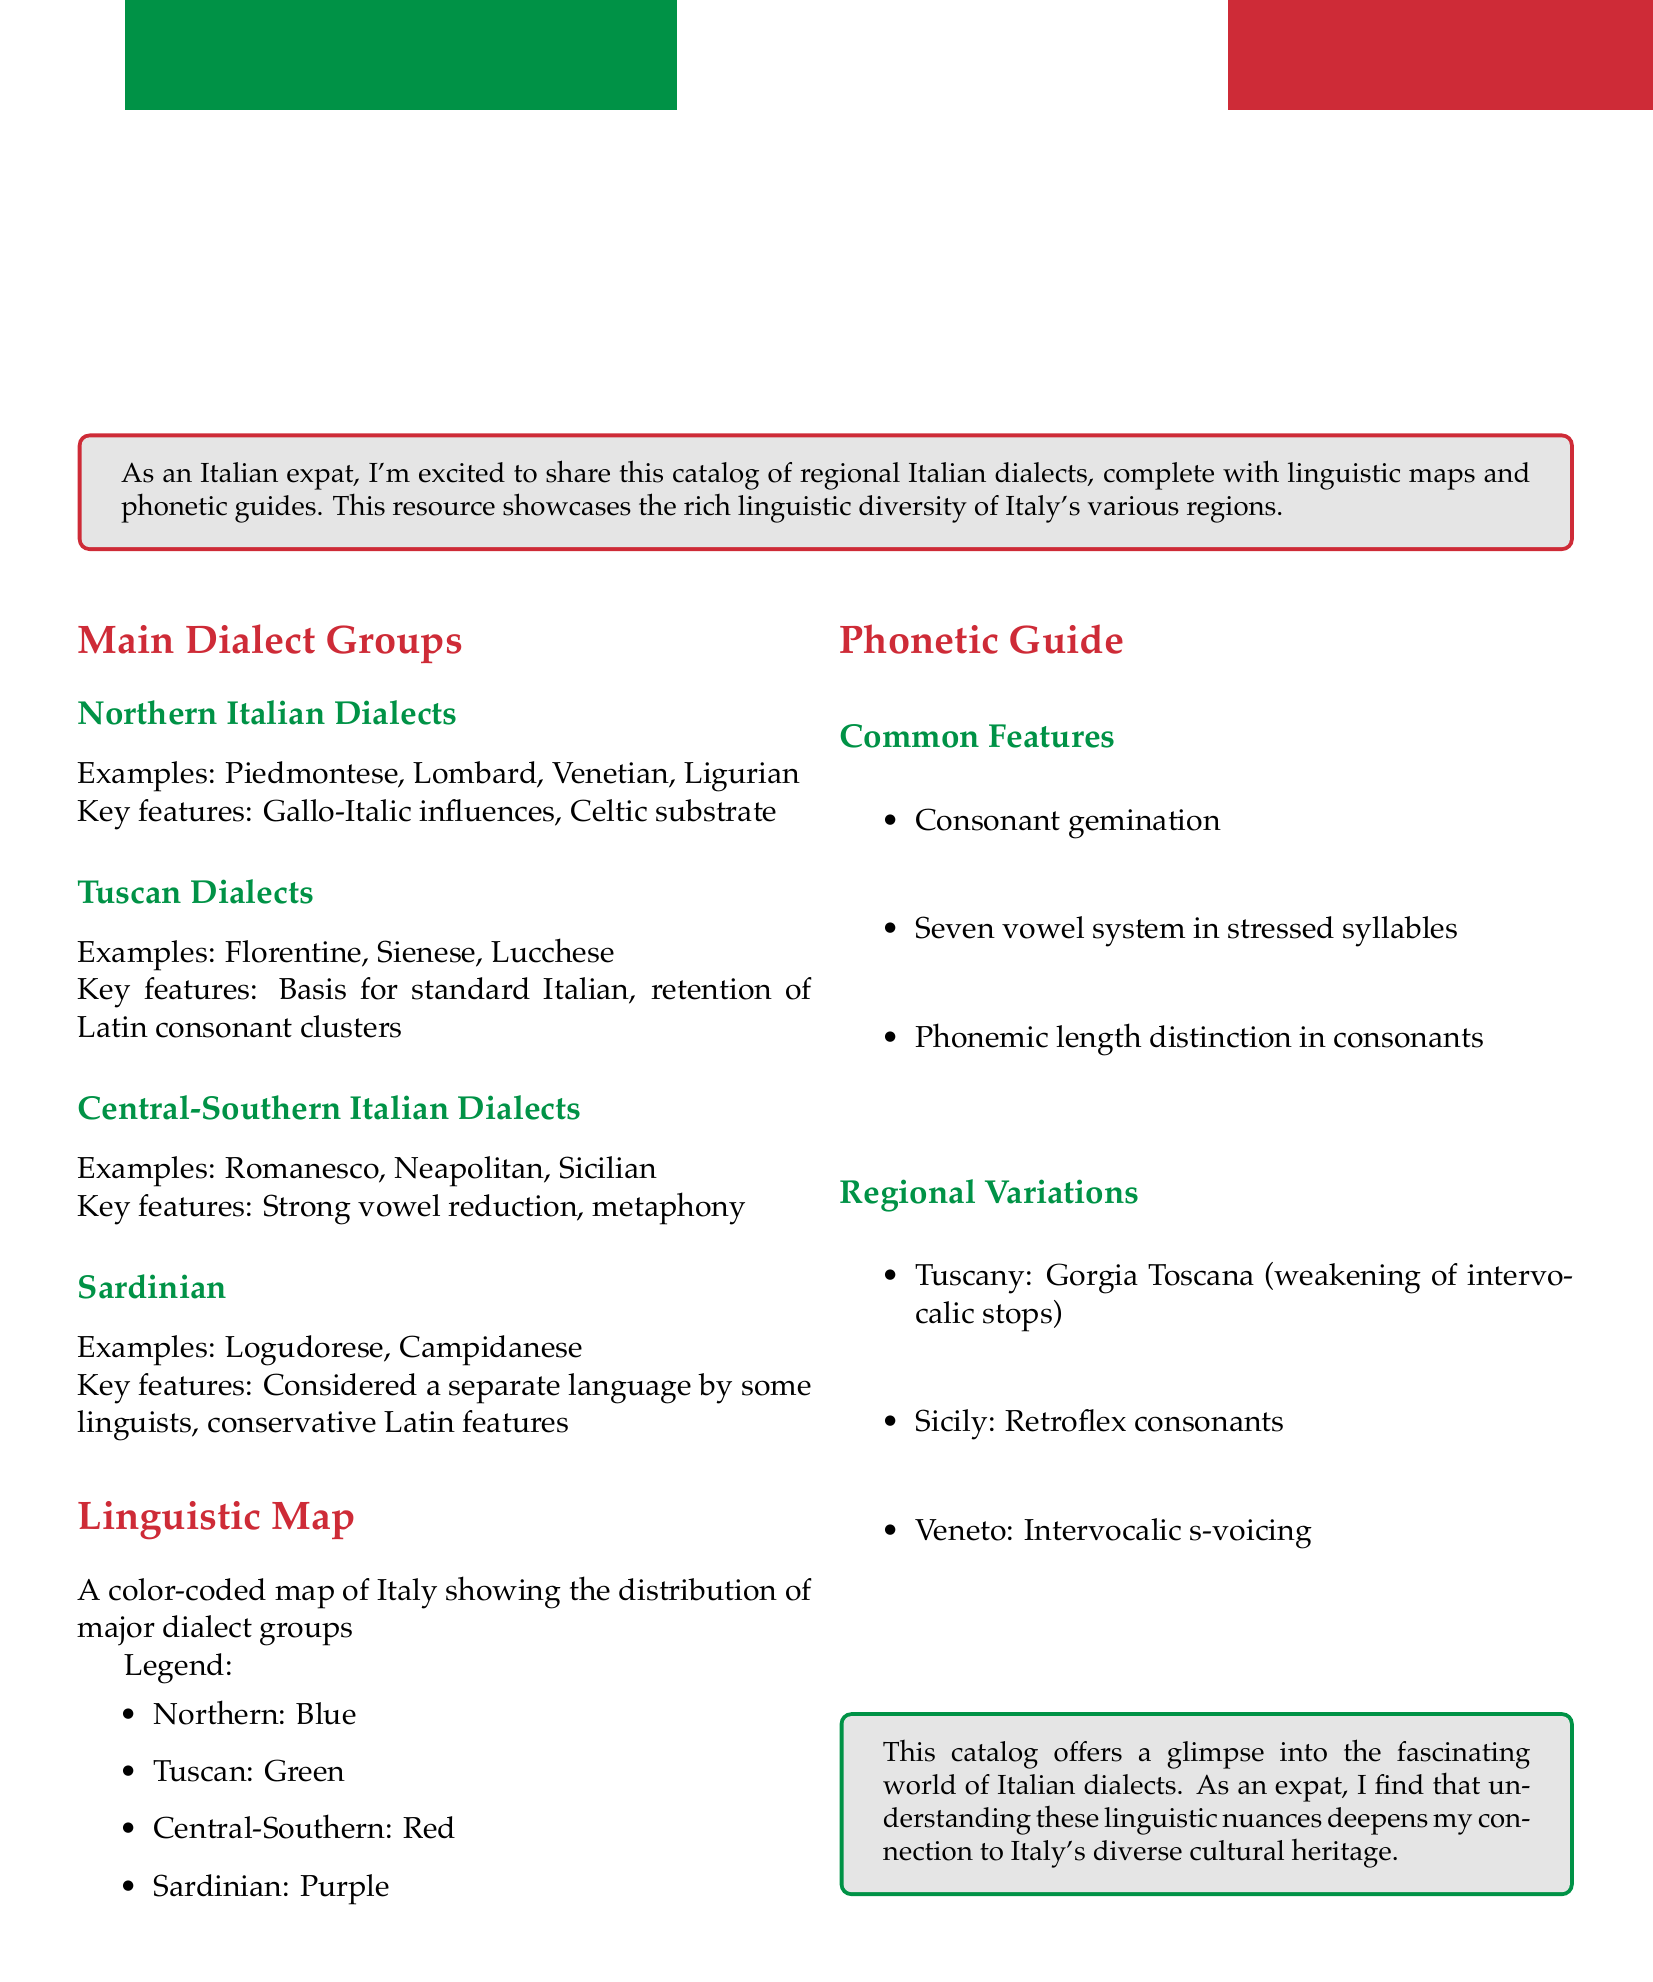What are the main dialect groups? The document lists the main dialect groups as Northern Italian Dialects, Tuscan Dialects, Central-Southern Italian Dialects, and Sardinian.
Answer: Northern Italian Dialects, Tuscan Dialects, Central-Southern Italian Dialects, Sardinian Which dialect is the basis for standard Italian? The document mentions that Tuscan dialects are the basis for standard Italian.
Answer: Tuscan Dialects What color represents Central-Southern dialects in the linguistic map? The document states that Central-Southern dialects are represented by the color red on the linguistic map.
Answer: Red What phonetic feature is common across the dialects? According to the document, a common phonetic feature is consonant gemination.
Answer: Consonant gemination Which dialect is associated with retroflex consonants? The document indicates that retroflex consonants are a variation found in Sicilian.
Answer: Sicilian What linguistic influence is found in Northern Italian dialects? The document states that Northern Italian dialects have Gallo-Italic influences.
Answer: Gallo-Italic influences What is the total number of vowel sounds in stressed syllables? The document indicates there is a seven vowel system in stressed syllables.
Answer: Seven What does the catalog aim to showcase? The document mentions it showcases the rich linguistic diversity of Italy's various regions.
Answer: Linguistic diversity What linguistic feature is specific to Tuscany? The document describes Gorgia Toscana as a phonetic feature specific to Tuscany.
Answer: Gorgia Toscana 